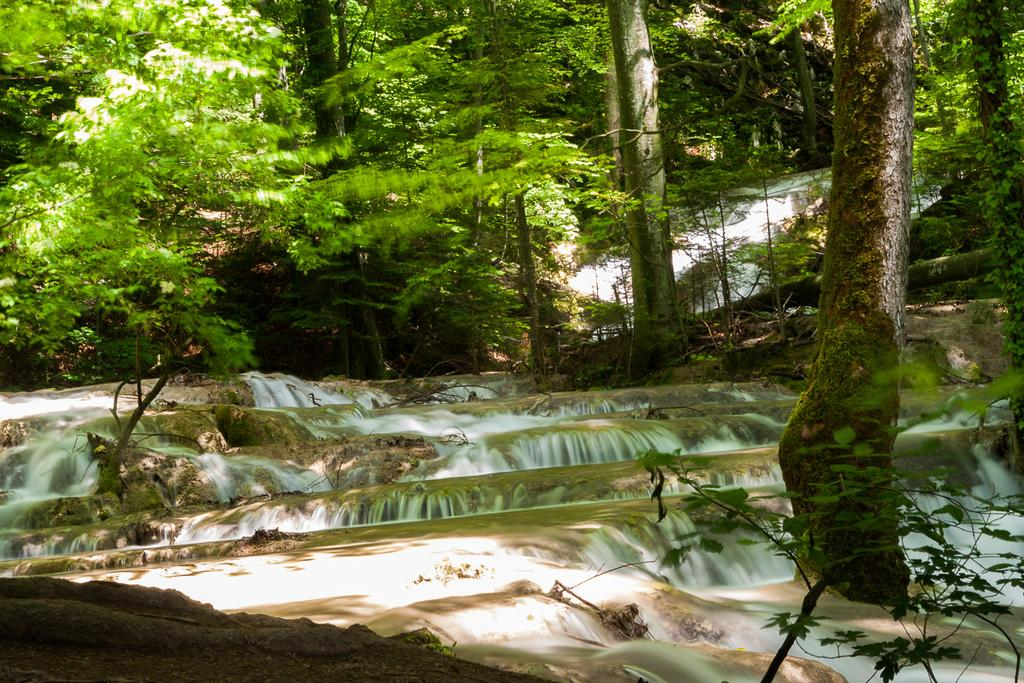What type of vegetation can be seen in the image? There are plants and trees in the image. What natural feature is present in the image? There is a waterfall in the image. What scientific advice can be seen in the image? There is no scientific advice present in the image; it features plants, trees, and a waterfall. How many trains are visible in the image? There are no trains present in the image. 